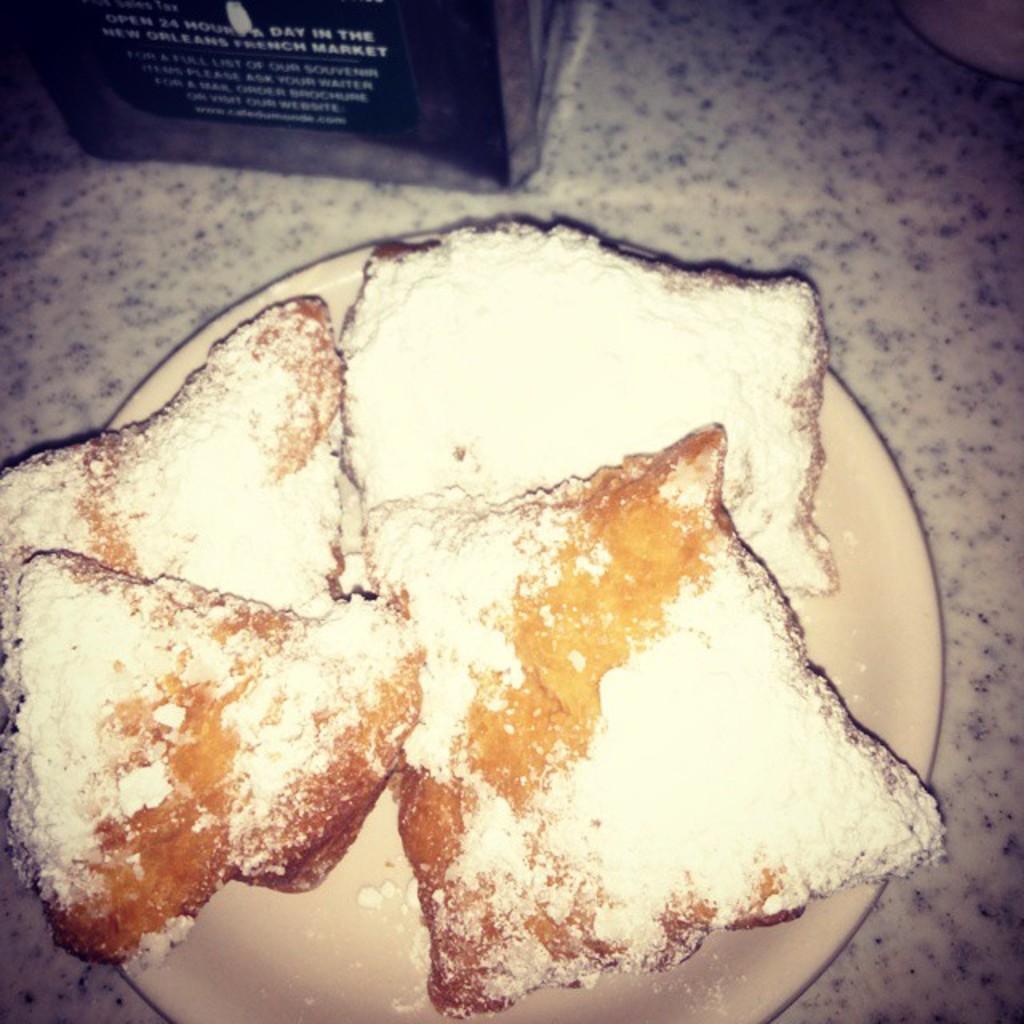Please provide a concise description of this image. In the middle of the image there is a plate with food items on the floor. At the top of the image there are two objects on the floor. 